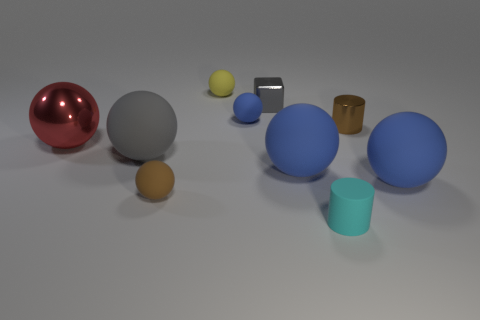Subtract all blue blocks. How many blue balls are left? 3 Subtract all yellow balls. How many balls are left? 6 Subtract all big blue spheres. How many spheres are left? 5 Subtract 2 spheres. How many spheres are left? 5 Subtract all gray balls. Subtract all purple cubes. How many balls are left? 6 Subtract all cubes. How many objects are left? 9 Subtract 0 yellow cubes. How many objects are left? 10 Subtract all tiny red rubber cubes. Subtract all red shiny objects. How many objects are left? 9 Add 6 tiny yellow rubber balls. How many tiny yellow rubber balls are left? 7 Add 10 large purple matte spheres. How many large purple matte spheres exist? 10 